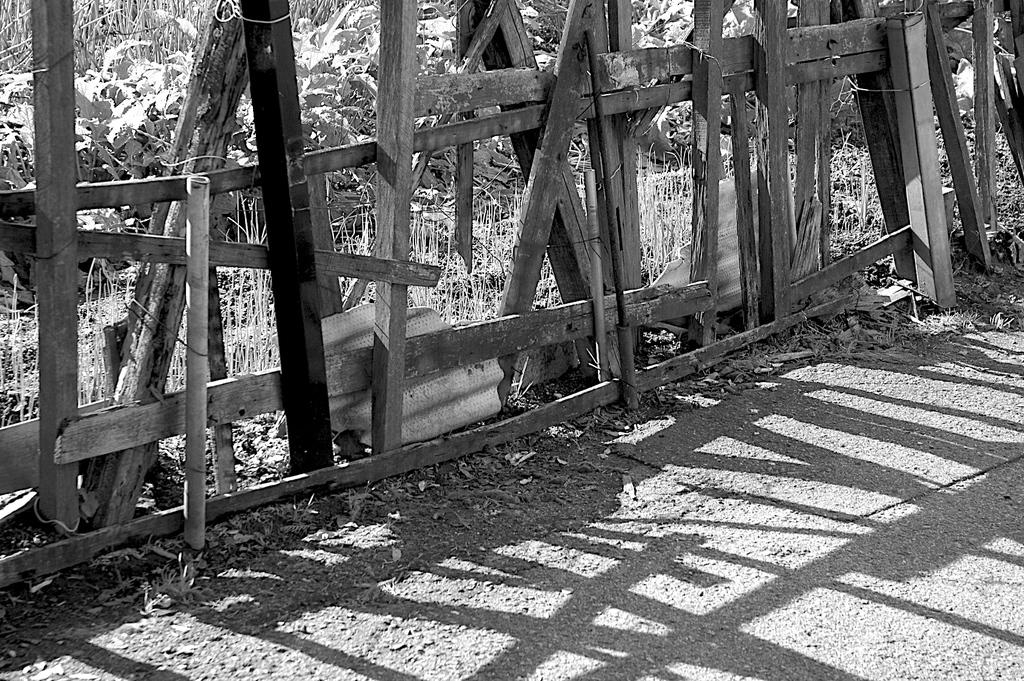What is located in the middle of the image? There is a wooden fence in the middle of the image. What can be seen in the background of the image? There are plants in the background of the image. What type of material is present at the bottom of the image? There are stones at the bottom of the image. How is the image presented in terms of color? The image is black and white. Can you see a horse playing volleyball with a sheet in the image? No, there is no horse, volleyball, or sheet present in the image. 